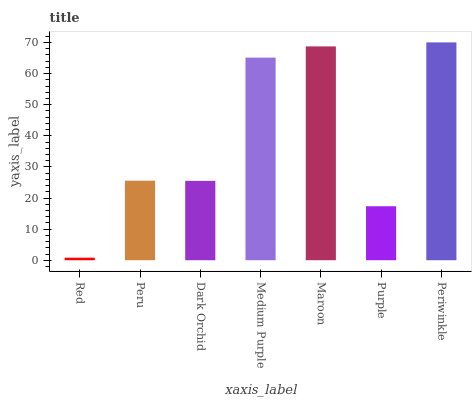Is Red the minimum?
Answer yes or no. Yes. Is Periwinkle the maximum?
Answer yes or no. Yes. Is Peru the minimum?
Answer yes or no. No. Is Peru the maximum?
Answer yes or no. No. Is Peru greater than Red?
Answer yes or no. Yes. Is Red less than Peru?
Answer yes or no. Yes. Is Red greater than Peru?
Answer yes or no. No. Is Peru less than Red?
Answer yes or no. No. Is Peru the high median?
Answer yes or no. Yes. Is Peru the low median?
Answer yes or no. Yes. Is Red the high median?
Answer yes or no. No. Is Periwinkle the low median?
Answer yes or no. No. 